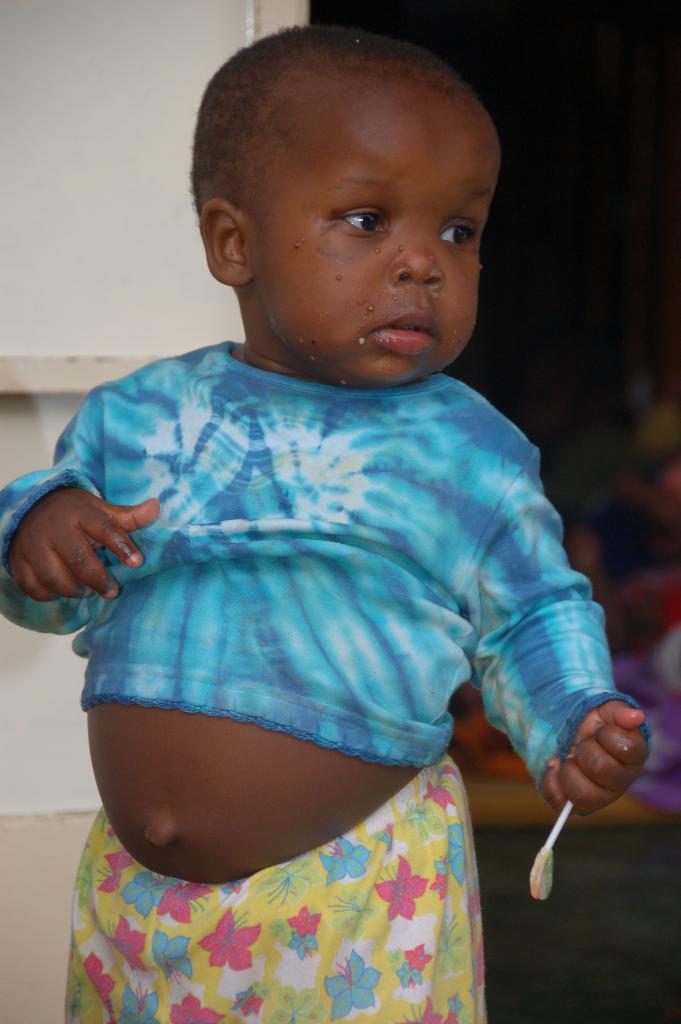In one or two sentences, can you explain what this image depicts? Here I can see a baby holding an object in the hand, standing and looking at the right side. On the left side there is a wall. In the background there are few objects on the floor. 